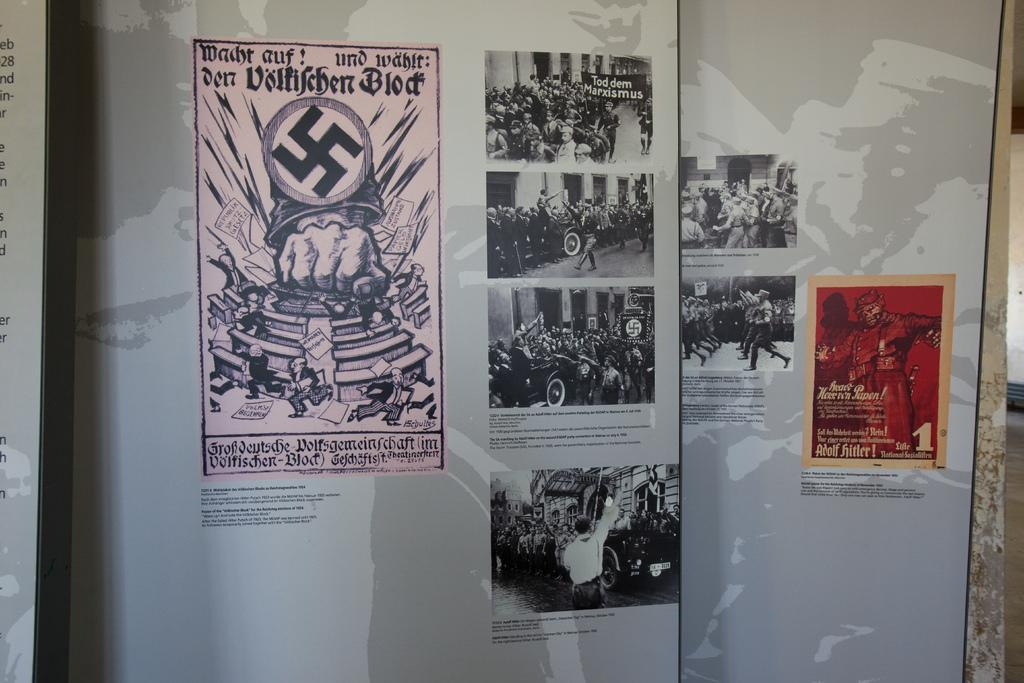What is displayed on the banners in the image? The banners contain posters related to communism. Are there any words or phrases on the banners? Yes, there is text on the banners. What can be seen on the right side of the image? There is a well on the right side of the image. What type of silver material is used to construct the well in the image? There is no mention of silver material in the image; the well's construction is not described. How deep is the snow around the well in the image? There is no snow present in the image; the ground appears clear. 